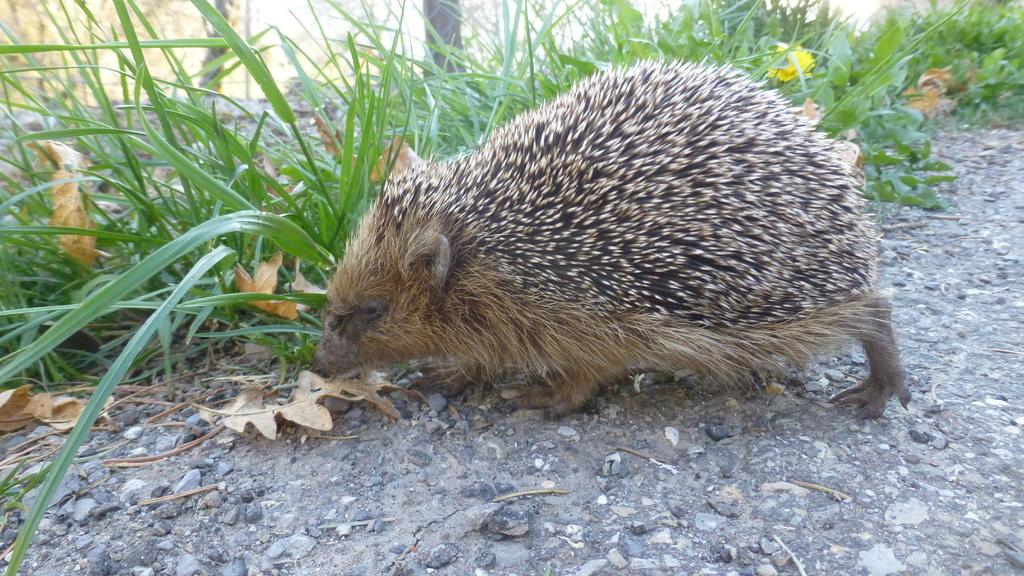What type of animal is in the image? There is a hedgehog in the image. Where is the hedgehog located? The hedgehog is on the ground. What else can be seen on the ground in the image? There are stones on the ground in the image. What can be seen in the background of the image? There is grass visible in the background of the image. What type of can is visible in the image? There is no can present in the image. Where is the screw located in the image? There is no screw present in the image. 